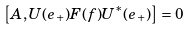<formula> <loc_0><loc_0><loc_500><loc_500>\left [ A , U ( e _ { + } ) F ( f ) U ^ { \ast } ( e _ { + } ) \right ] = 0</formula> 